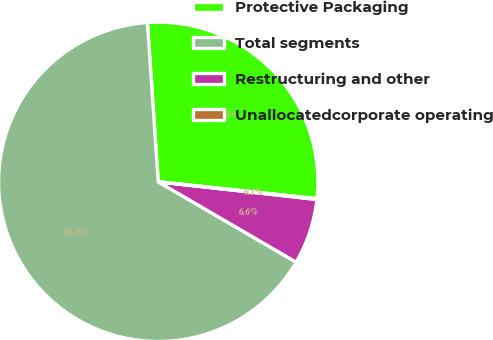Convert chart. <chart><loc_0><loc_0><loc_500><loc_500><pie_chart><fcel>Protective Packaging<fcel>Total segments<fcel>Restructuring and other<fcel>Unallocatedcorporate operating<nl><fcel>27.76%<fcel>65.52%<fcel>6.63%<fcel>0.08%<nl></chart> 